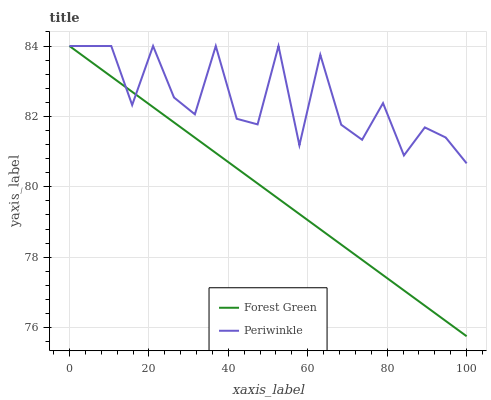Does Forest Green have the minimum area under the curve?
Answer yes or no. Yes. Does Periwinkle have the maximum area under the curve?
Answer yes or no. Yes. Does Periwinkle have the minimum area under the curve?
Answer yes or no. No. Is Forest Green the smoothest?
Answer yes or no. Yes. Is Periwinkle the roughest?
Answer yes or no. Yes. Is Periwinkle the smoothest?
Answer yes or no. No. Does Forest Green have the lowest value?
Answer yes or no. Yes. Does Periwinkle have the lowest value?
Answer yes or no. No. Does Periwinkle have the highest value?
Answer yes or no. Yes. Does Forest Green intersect Periwinkle?
Answer yes or no. Yes. Is Forest Green less than Periwinkle?
Answer yes or no. No. Is Forest Green greater than Periwinkle?
Answer yes or no. No. 